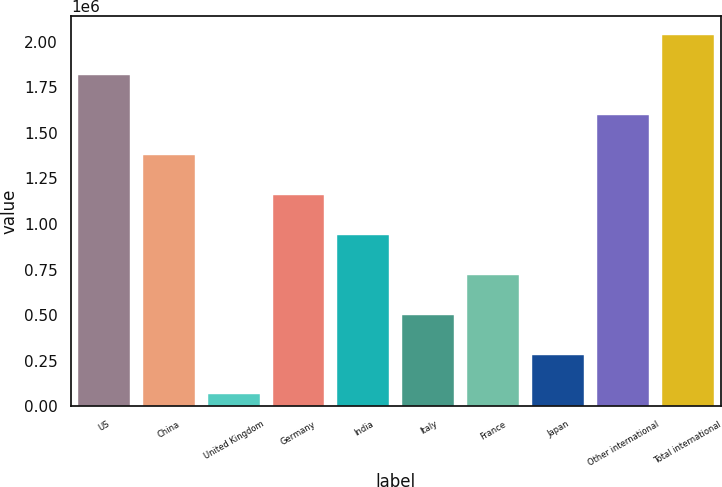<chart> <loc_0><loc_0><loc_500><loc_500><bar_chart><fcel>US<fcel>China<fcel>United Kingdom<fcel>Germany<fcel>India<fcel>Italy<fcel>France<fcel>Japan<fcel>Other international<fcel>Total international<nl><fcel>1.81862e+06<fcel>1.38025e+06<fcel>65164<fcel>1.16107e+06<fcel>941891<fcel>503528<fcel>722709<fcel>284346<fcel>1.59944e+06<fcel>2.0378e+06<nl></chart> 